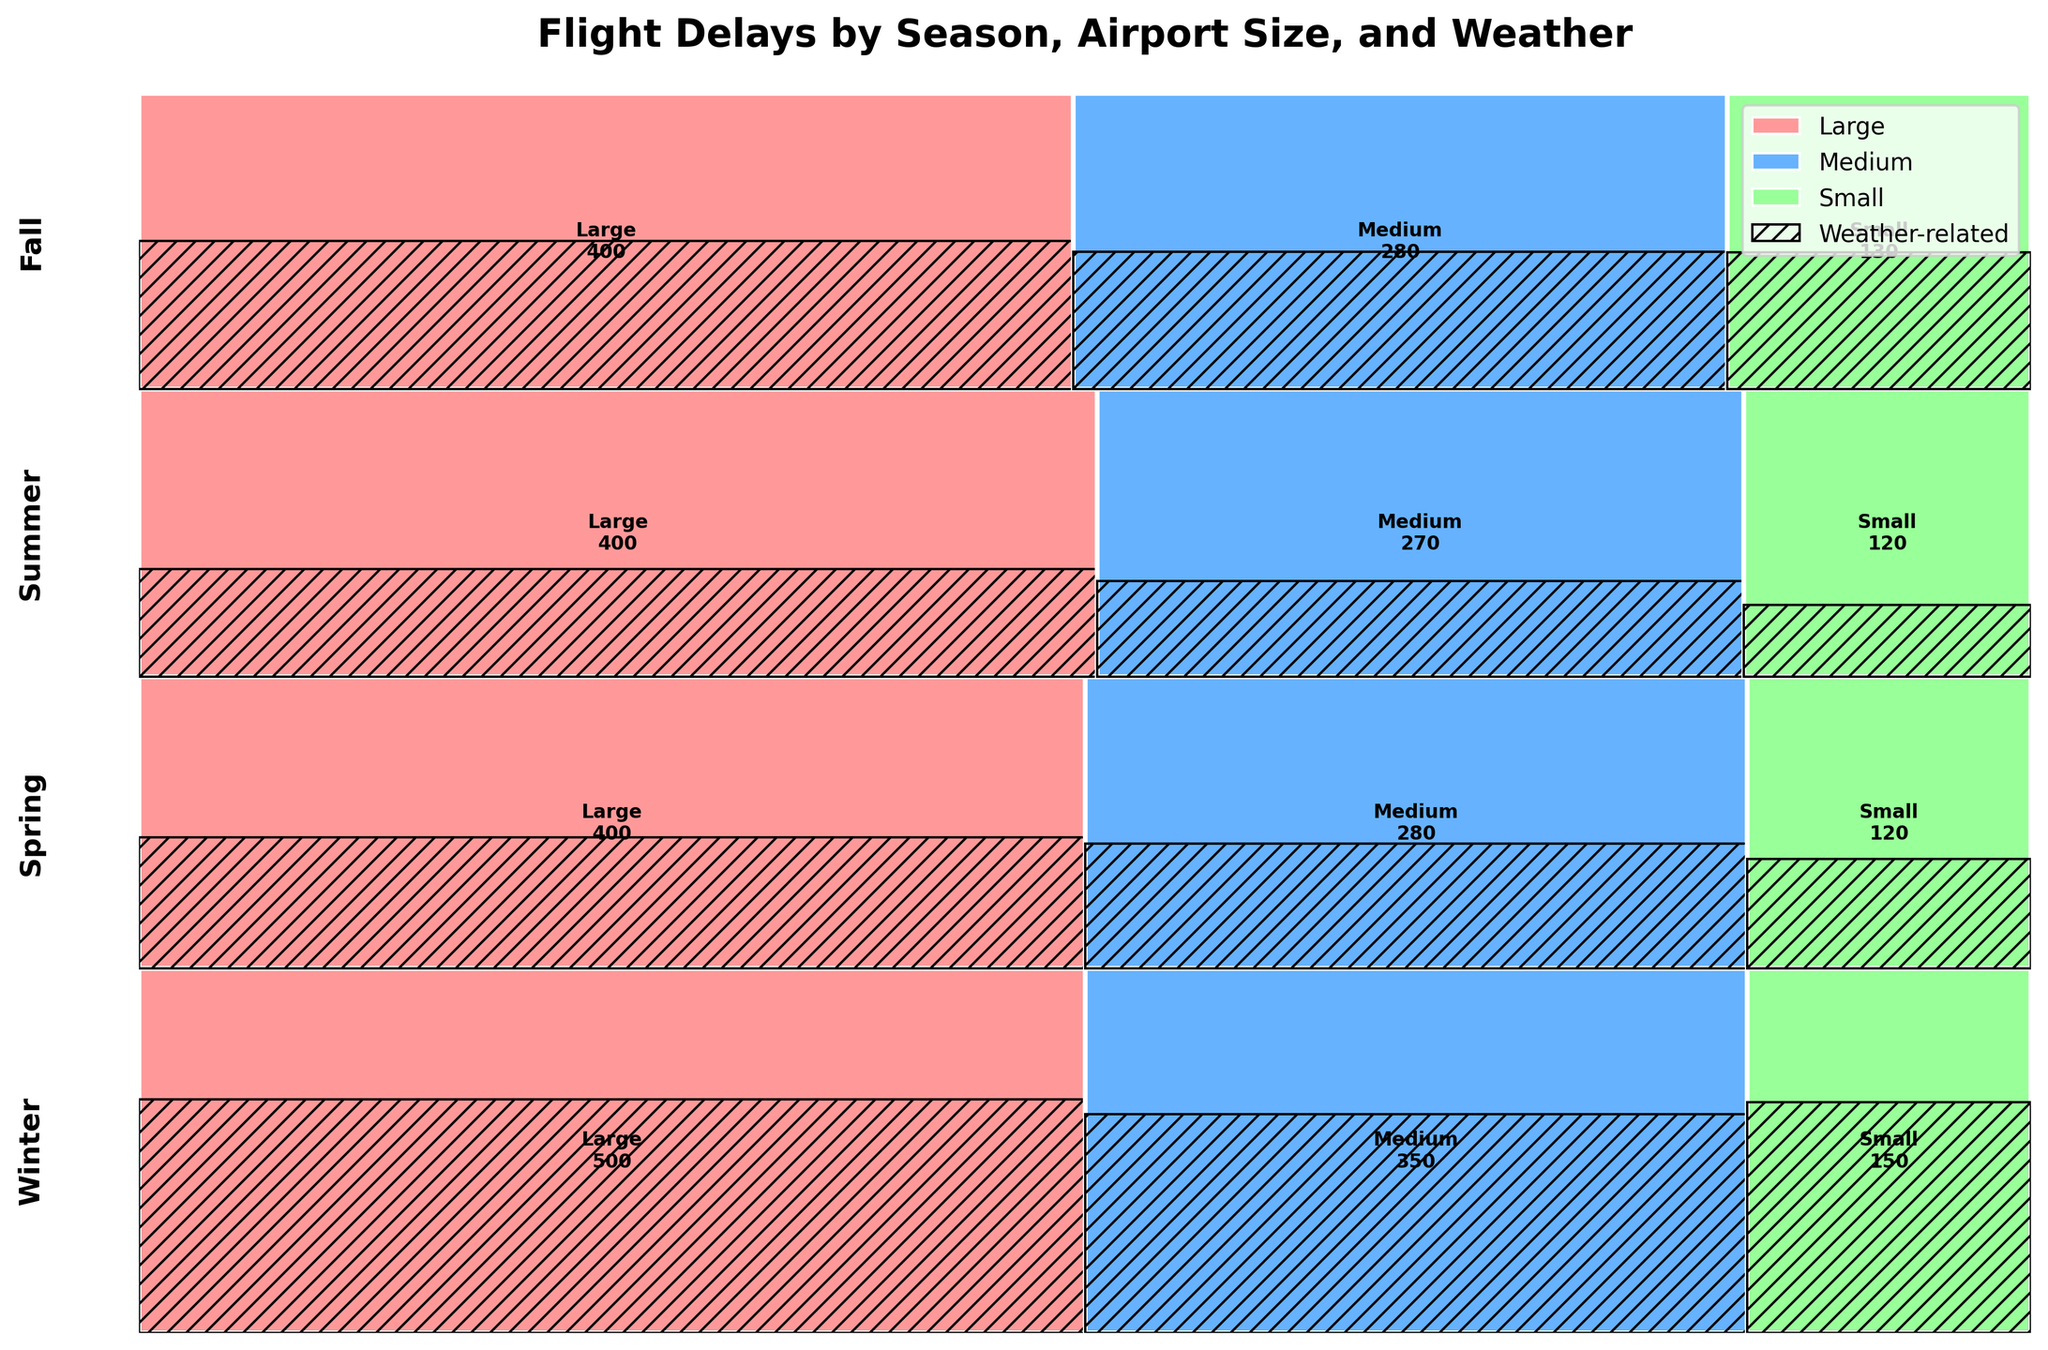Which season has the highest total number of flight delays? To find the season with the highest total number of flight delays, sum up both weather-related and non-weather-related delays for each season and compare. Winter has 320+180+210+140+95+55 = 1000 delays, Spring has 180+220+120+160+45+75 = 800 delays, Summer has 150+250+90+180+30+90 = 790 delays, and Fall has 200+200+130+150+60+70 = 810 delays. Therefore, Winter has the highest total number of flight delays.
Answer: Winter Which airport size sees the most weather-related delays in Summer? To identify which airport size sees the most weather-related delays in Summer, look at the weather-related delay counts for each airport size during Summer in the figure. Large airports have 150, Medium airports have 90, and Small airports have 30 weather-related delays. Therefore, Large airports see the most weather-related delays in Summer.
Answer: Large How do the number of weather-related flight delays in Winter compare for Large and Medium airports? To compare, look at the counts of weather-related delays in Winter for both Large and Medium airports. Large airports have 320 delays, while Medium airports have 210. Therefore, Large airports have more weather-related flight delays in Winter compared to Medium airports (320 vs. 210).
Answer: Large airports have more delays Which season has the least weather-related delays at Small airports? Examine the counts of weather-related delays for Small airports across all seasons in the figure. Winter has 95, Spring has 45, Summer has 30, and Fall has 60 weather-related delays. Therefore, Summer has the least weather-related delays at Small airports.
Answer: Summer What is the ratio of weather-related delays to non-weather-related delays at Medium airports in Fall? To determine the ratio, use the counts of weather-related and non-weather-related delays at Medium airports in Fall. The weather-related delays count is 130 and the non-weather-related is 150. The ratio is calculated as 130 / 150 = 0.87.
Answer: 0.87 Does Spring have more weather-related delays than Summer across all airport sizes? Sum up the weather-related delays for each airport size in both Spring and Summer and compare. Spring has 180 (Large) + 120 (Medium) + 45 (Small) = 345, and Summer has 150 (Large) + 90 (Medium) + 30 (Small) = 270. Therefore, Spring has more weather-related delays than Summer.
Answer: Yes What are the total delays for Small airports across all seasons? To find the total delays, add up the weather-related and non-weather-related delays for Small airports in all seasons. Winter has 95+55 = 150, Spring has 45+75 = 120, Summer has 30+90 = 120, and Fall has 60+70 = 130. Therefore, the total is 150+120+120+130 = 520.
Answer: 520 Which season has the smallest proportion of weather-related delays for Medium airports? To determine the smallest proportion, calculate the proportion of weather-related delays to total delays for Medium airports in each season. Winter: 210/(210+140) = 0.6, Spring: 120/(120+160) = 0.43, Summer: 90/(90+180) = 0.33, Fall: 130/(130+150) = 0.46. Therefore, Summer has the smallest proportion of weather-related delays for Medium airports.
Answer: Summer 